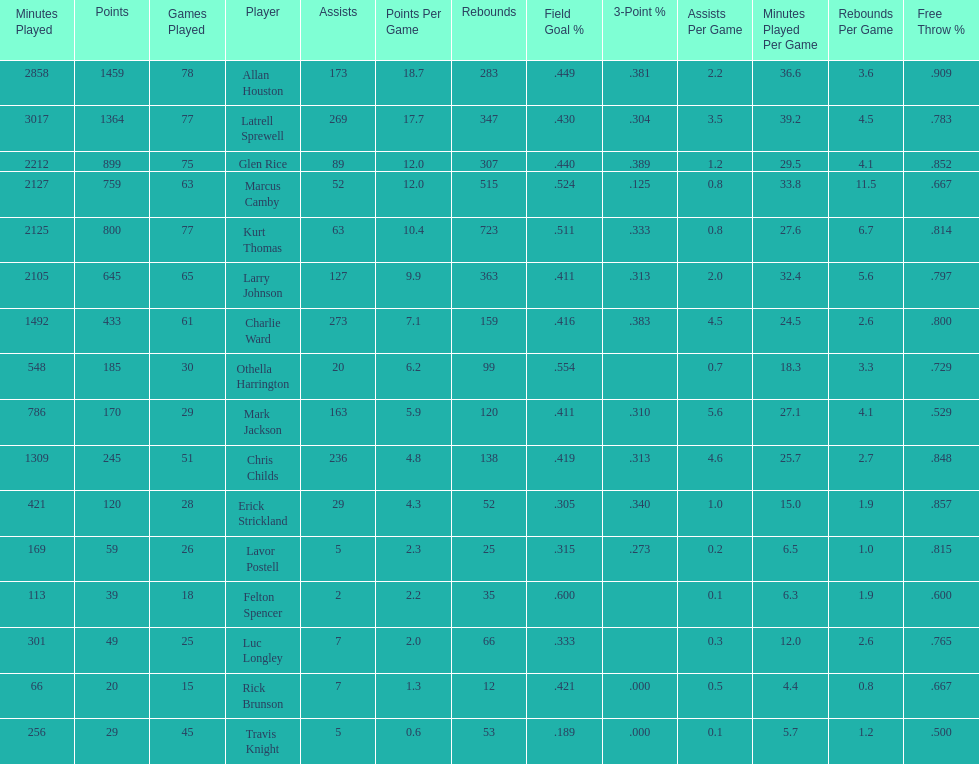Number of players on the team. 16. 